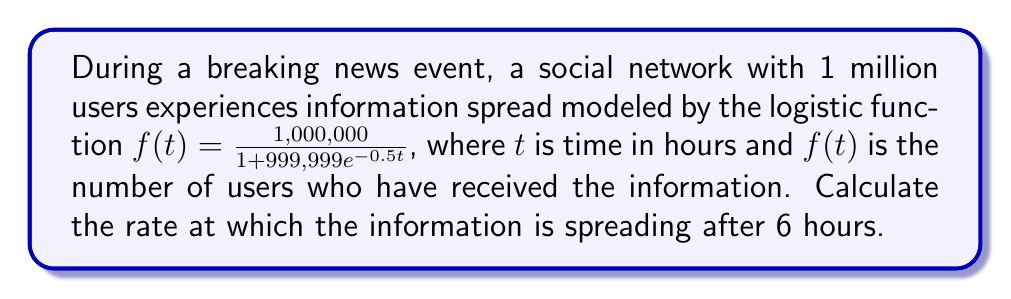Provide a solution to this math problem. To find the rate of information spread at a specific time, we need to calculate the derivative of the logistic function at that point. Let's approach this step-by-step:

1) The given logistic function is:
   $$f(t) = \frac{1,000,000}{1 + 999,999e^{-0.5t}}$$

2) To find the rate of change, we need to differentiate this function. The derivative of a logistic function of the form $\frac{L}{1 + ae^{-kt}}$ is:
   $$f'(t) = \frac{kLae^{-kt}}{(1 + ae^{-kt})^2}$$

3) In our case, $L = 1,000,000$, $a = 999,999$, and $k = 0.5$. Substituting these values:
   $$f'(t) = \frac{0.5 \cdot 1,000,000 \cdot 999,999e^{-0.5t}}{(1 + 999,999e^{-0.5t})^2}$$

4) Simplify:
   $$f'(t) = \frac{499,999,500e^{-0.5t}}{(1 + 999,999e^{-0.5t})^2}$$

5) Now, we need to evaluate this at $t = 6$:
   $$f'(6) = \frac{499,999,500e^{-0.5(6)}}{(1 + 999,999e^{-0.5(6)})^2}$$

6) Calculate $e^{-0.5(6)} \approx 0.0497870684$:
   $$f'(6) = \frac{499,999,500 \cdot 0.0497870684}{(1 + 999,999 \cdot 0.0497870684)^2}$$

7) Evaluate:
   $$f'(6) \approx 124,998.7$$

Therefore, after 6 hours, the information is spreading at a rate of approximately 124,999 users per hour.
Answer: 124,999 users/hour 